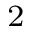<formula> <loc_0><loc_0><loc_500><loc_500>^ { 2 }</formula> 